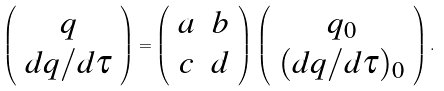Convert formula to latex. <formula><loc_0><loc_0><loc_500><loc_500>\left ( \begin{array} { c } q \\ d q / d \tau \end{array} \right ) = \left ( \begin{array} { c c } a & b \\ c & d \end{array} \right ) \, \left ( \begin{array} { c } q _ { 0 } \\ ( d q / d \tau ) _ { 0 } \end{array} \right ) .</formula> 